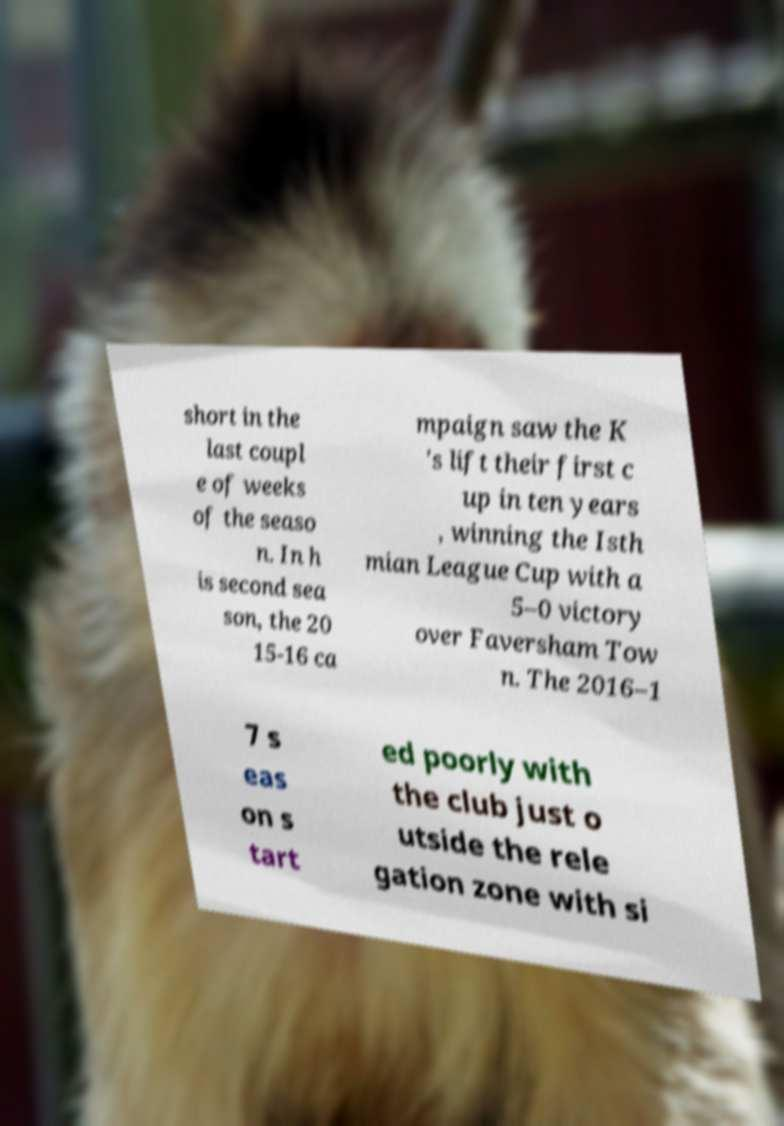I need the written content from this picture converted into text. Can you do that? short in the last coupl e of weeks of the seaso n. In h is second sea son, the 20 15-16 ca mpaign saw the K 's lift their first c up in ten years , winning the Isth mian League Cup with a 5–0 victory over Faversham Tow n. The 2016–1 7 s eas on s tart ed poorly with the club just o utside the rele gation zone with si 